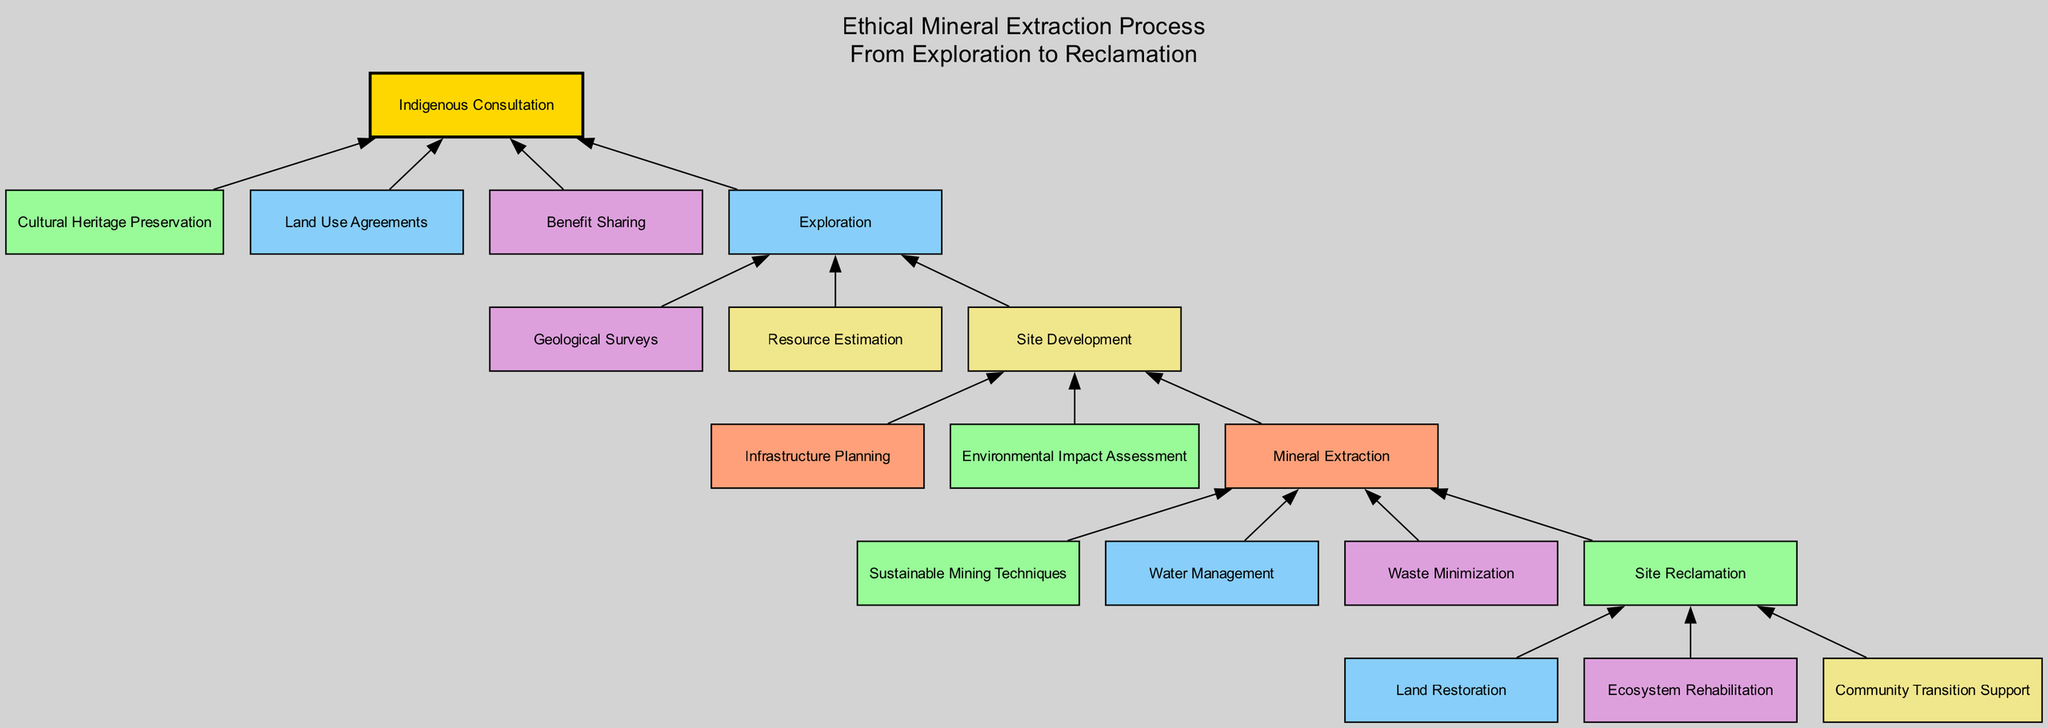What is the final step in the mining process? The final step in the mining process, as shown in the diagram, is "Site Reclamation." This is the last node before the diagram concludes, indicating that it's the endpoint of the ethical mineral extraction process.
Answer: Site Reclamation How many children nodes does "Mineral Extraction" have? The "Mineral Extraction" node has four children nodes: "Site Reclamation," "Sustainable Mining Techniques," "Water Management," and "Waste Minimization." Counting these gives a total of four children.
Answer: 4 Which node is directly linked to "Exploration"? The "Exploration" node is directly linked to three nodes: "Site Development," "Geological Surveys," and "Resource Estimation." The relationships can be traced by following the edges coming from the "Exploration" node.
Answer: Site Development What is highlighted in the diagram to emphasize its importance? The node "Indigenous Consultation" is highlighted in the diagram with a different color (gold) and has a thicker outline (penwidth of 2) than other nodes. This visual distinction signifies its importance within the ethical mineral extraction process.
Answer: Indigenous Consultation How many stages are there in the diagram before "Site Reclamation"? Before reaching "Site Reclamation," the stages include "Mineral Extraction," "Site Development," and "Exploration." Counting these nodes reveals there are three stages before "Site Reclamation."
Answer: 3 Which process focuses on "Cultural Heritage Preservation"? The process that focuses on "Cultural Heritage Preservation" is included under the "Indigenous Consultation" node. This indicates that cultural heritage is an essential consideration when engaging with indigenous communities during mineral extraction.
Answer: Cultural Heritage Preservation What is the main purpose of "Water Management"? The purpose of "Water Management" in the context of this diagram is to ensure that water resources are utilized and preserved sustainably during the mining operations, thereby minimizing environmental impact. This function is represented as a child node under "Mineral Extraction."
Answer: Water Management What relationships can be identified between "Exploration" and "Indigenous Consultation"? "Indigenous Consultation" is positioned as a foundational step that precedes "Exploration." The relationship highlights that consulting indigenous communities is essential before any exploratory activities take place, emphasizing ethical practices in the mining process.
Answer: Ethical practices Which node includes both "Benefit Sharing" and "Land Use Agreements"? The node that includes both "Benefit Sharing" and "Land Use Agreements" is "Indigenous Consultation." These aspects are critical components of the broader process of engaging with indigenous peoples in mining activities.
Answer: Indigenous Consultation 